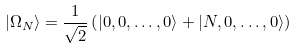<formula> <loc_0><loc_0><loc_500><loc_500>| \Omega _ { N } \rangle = \frac { 1 } { \sqrt { 2 } } \left ( | 0 , 0 , \dots , 0 \rangle + | N , 0 , \dots , 0 \rangle \right )</formula> 